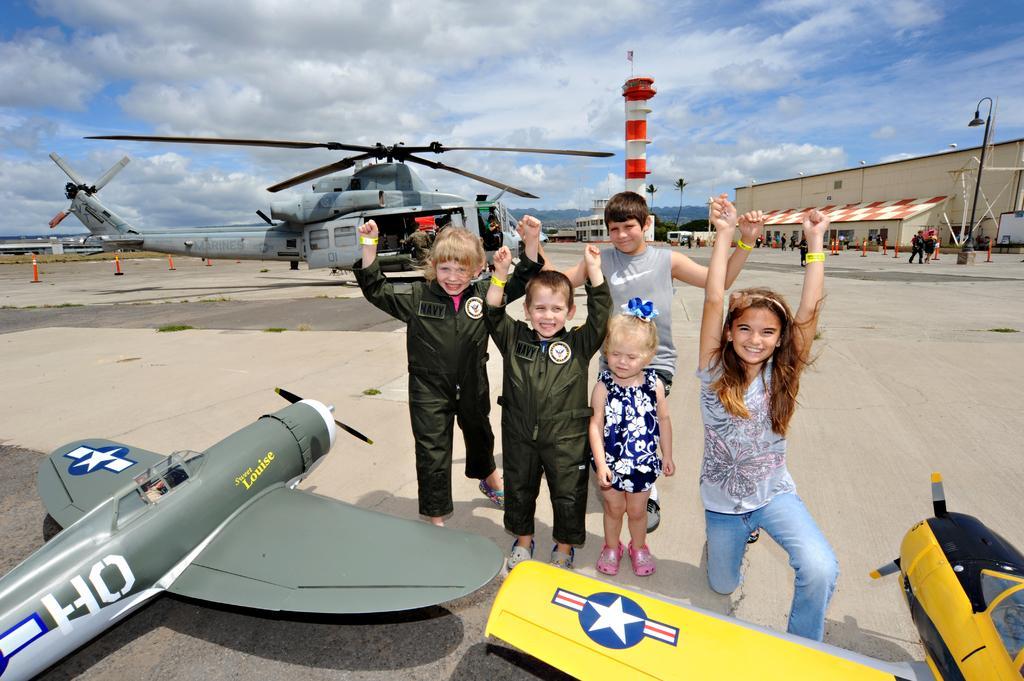Can you describe this image briefly? In this image we can see some group of kids standing, at the foreground of the image there are some aircraft and at the background of the image there is helicopter and some persons walking, hangar, building, tower and sunny sky. 